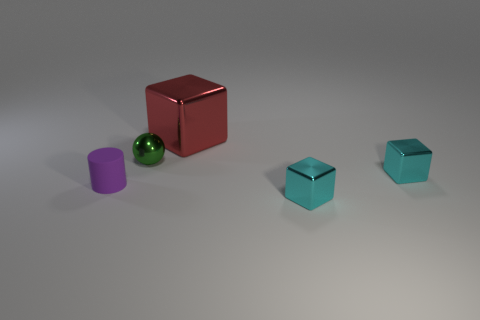How many objects are there in total in the image? There are a total of four objects in the image: one tiny purple cylinder, one small shiny green sphere, and two small teal-colored cubes. 